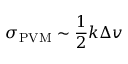Convert formula to latex. <formula><loc_0><loc_0><loc_500><loc_500>\sigma _ { P V M } \sim \frac { 1 } { 2 } k \Delta v</formula> 